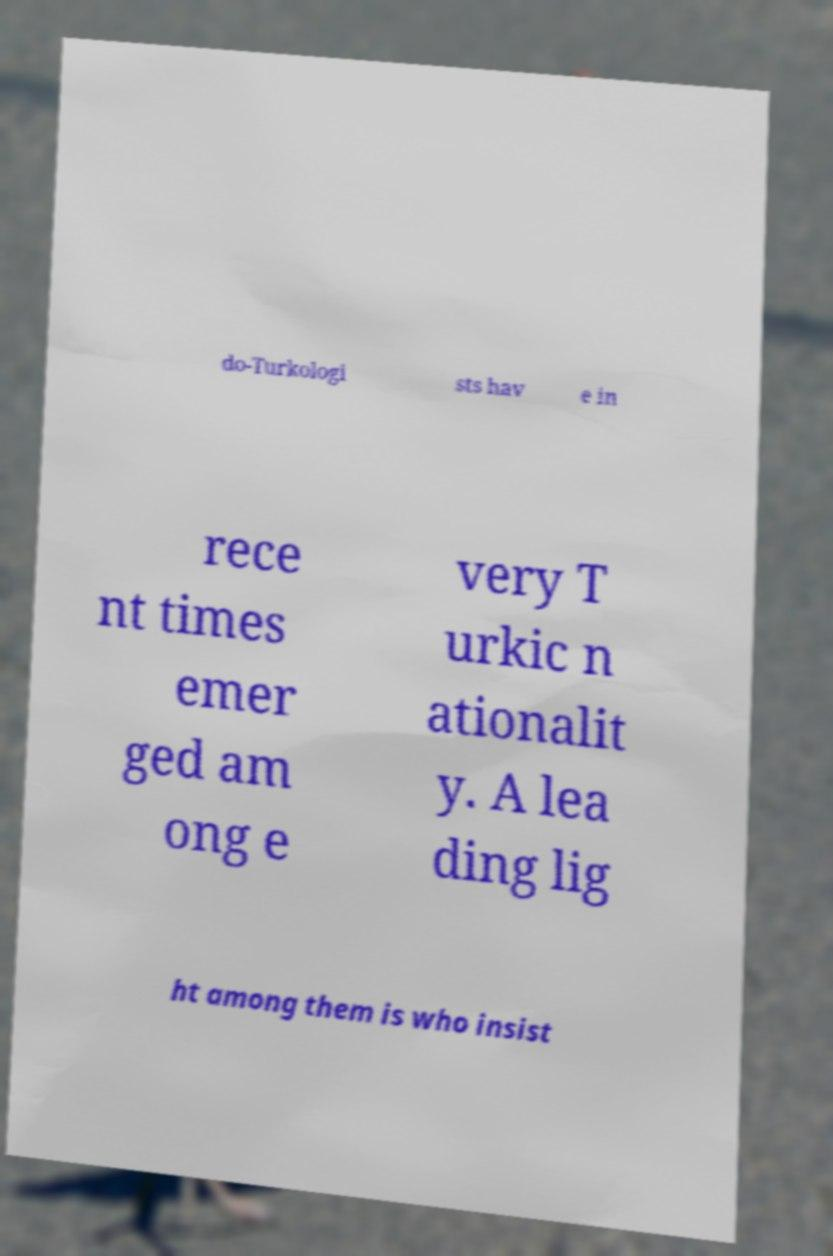Can you accurately transcribe the text from the provided image for me? do-Turkologi sts hav e in rece nt times emer ged am ong e very T urkic n ationalit y. A lea ding lig ht among them is who insist 